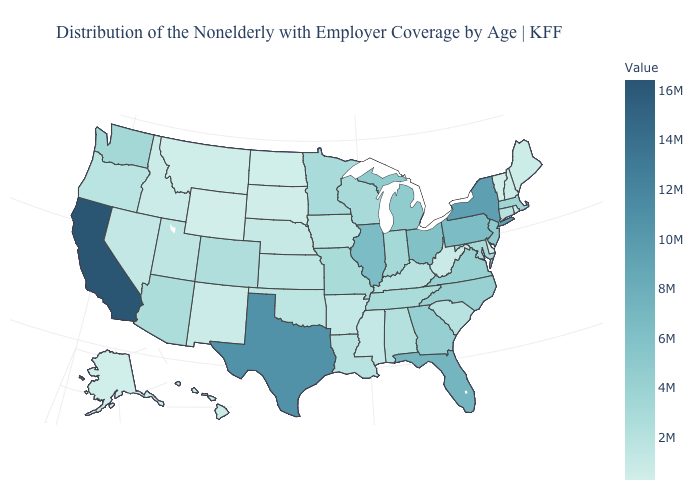Does Connecticut have a lower value than Georgia?
Write a very short answer. Yes. Among the states that border Idaho , which have the highest value?
Short answer required. Washington. Does New Jersey have the highest value in the Northeast?
Write a very short answer. No. Is the legend a continuous bar?
Quick response, please. Yes. Among the states that border Oregon , which have the highest value?
Quick response, please. California. Does Missouri have the highest value in the MidWest?
Short answer required. No. Does New York have the highest value in the Northeast?
Write a very short answer. Yes. Among the states that border South Carolina , does North Carolina have the highest value?
Be succinct. No. Does Oregon have a lower value than Michigan?
Keep it brief. Yes. 